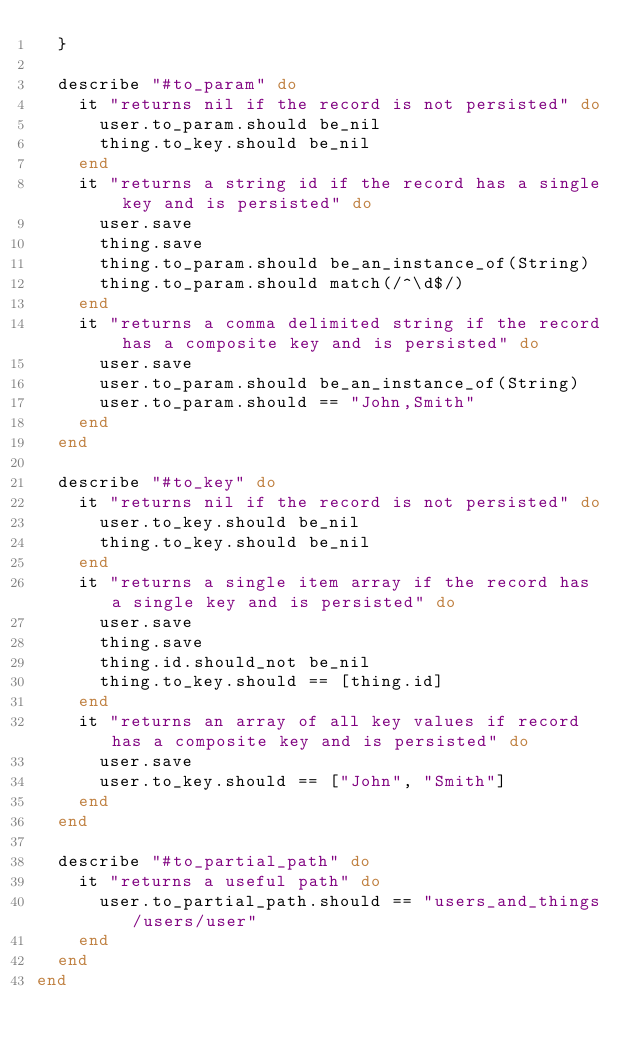<code> <loc_0><loc_0><loc_500><loc_500><_Ruby_>  }

  describe "#to_param" do
    it "returns nil if the record is not persisted" do
      user.to_param.should be_nil
      thing.to_key.should be_nil
    end
    it "returns a string id if the record has a single key and is persisted" do
      user.save
      thing.save
      thing.to_param.should be_an_instance_of(String)
      thing.to_param.should match(/^\d$/)
    end
    it "returns a comma delimited string if the record has a composite key and is persisted" do
      user.save
      user.to_param.should be_an_instance_of(String)
      user.to_param.should == "John,Smith"
    end
  end

  describe "#to_key" do
    it "returns nil if the record is not persisted" do
      user.to_key.should be_nil
      thing.to_key.should be_nil
    end
    it "returns a single item array if the record has a single key and is persisted" do
      user.save
      thing.save
      thing.id.should_not be_nil
      thing.to_key.should == [thing.id]
    end
    it "returns an array of all key values if record has a composite key and is persisted" do
      user.save
      user.to_key.should == ["John", "Smith"]
    end
  end

  describe "#to_partial_path" do
    it "returns a useful path" do
      user.to_partial_path.should == "users_and_things/users/user"
    end
  end
end
</code> 